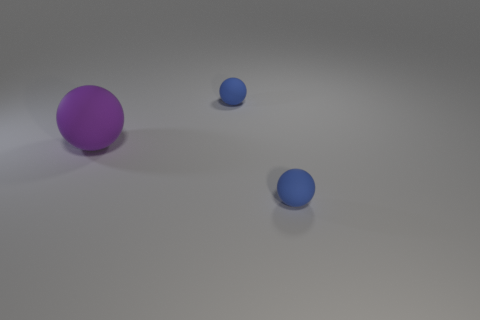Can you describe the colors visible in the image? Certainly! The image contains primarily shades of grey for the background, with three objects in differing shades of blue and a single object in purple. 